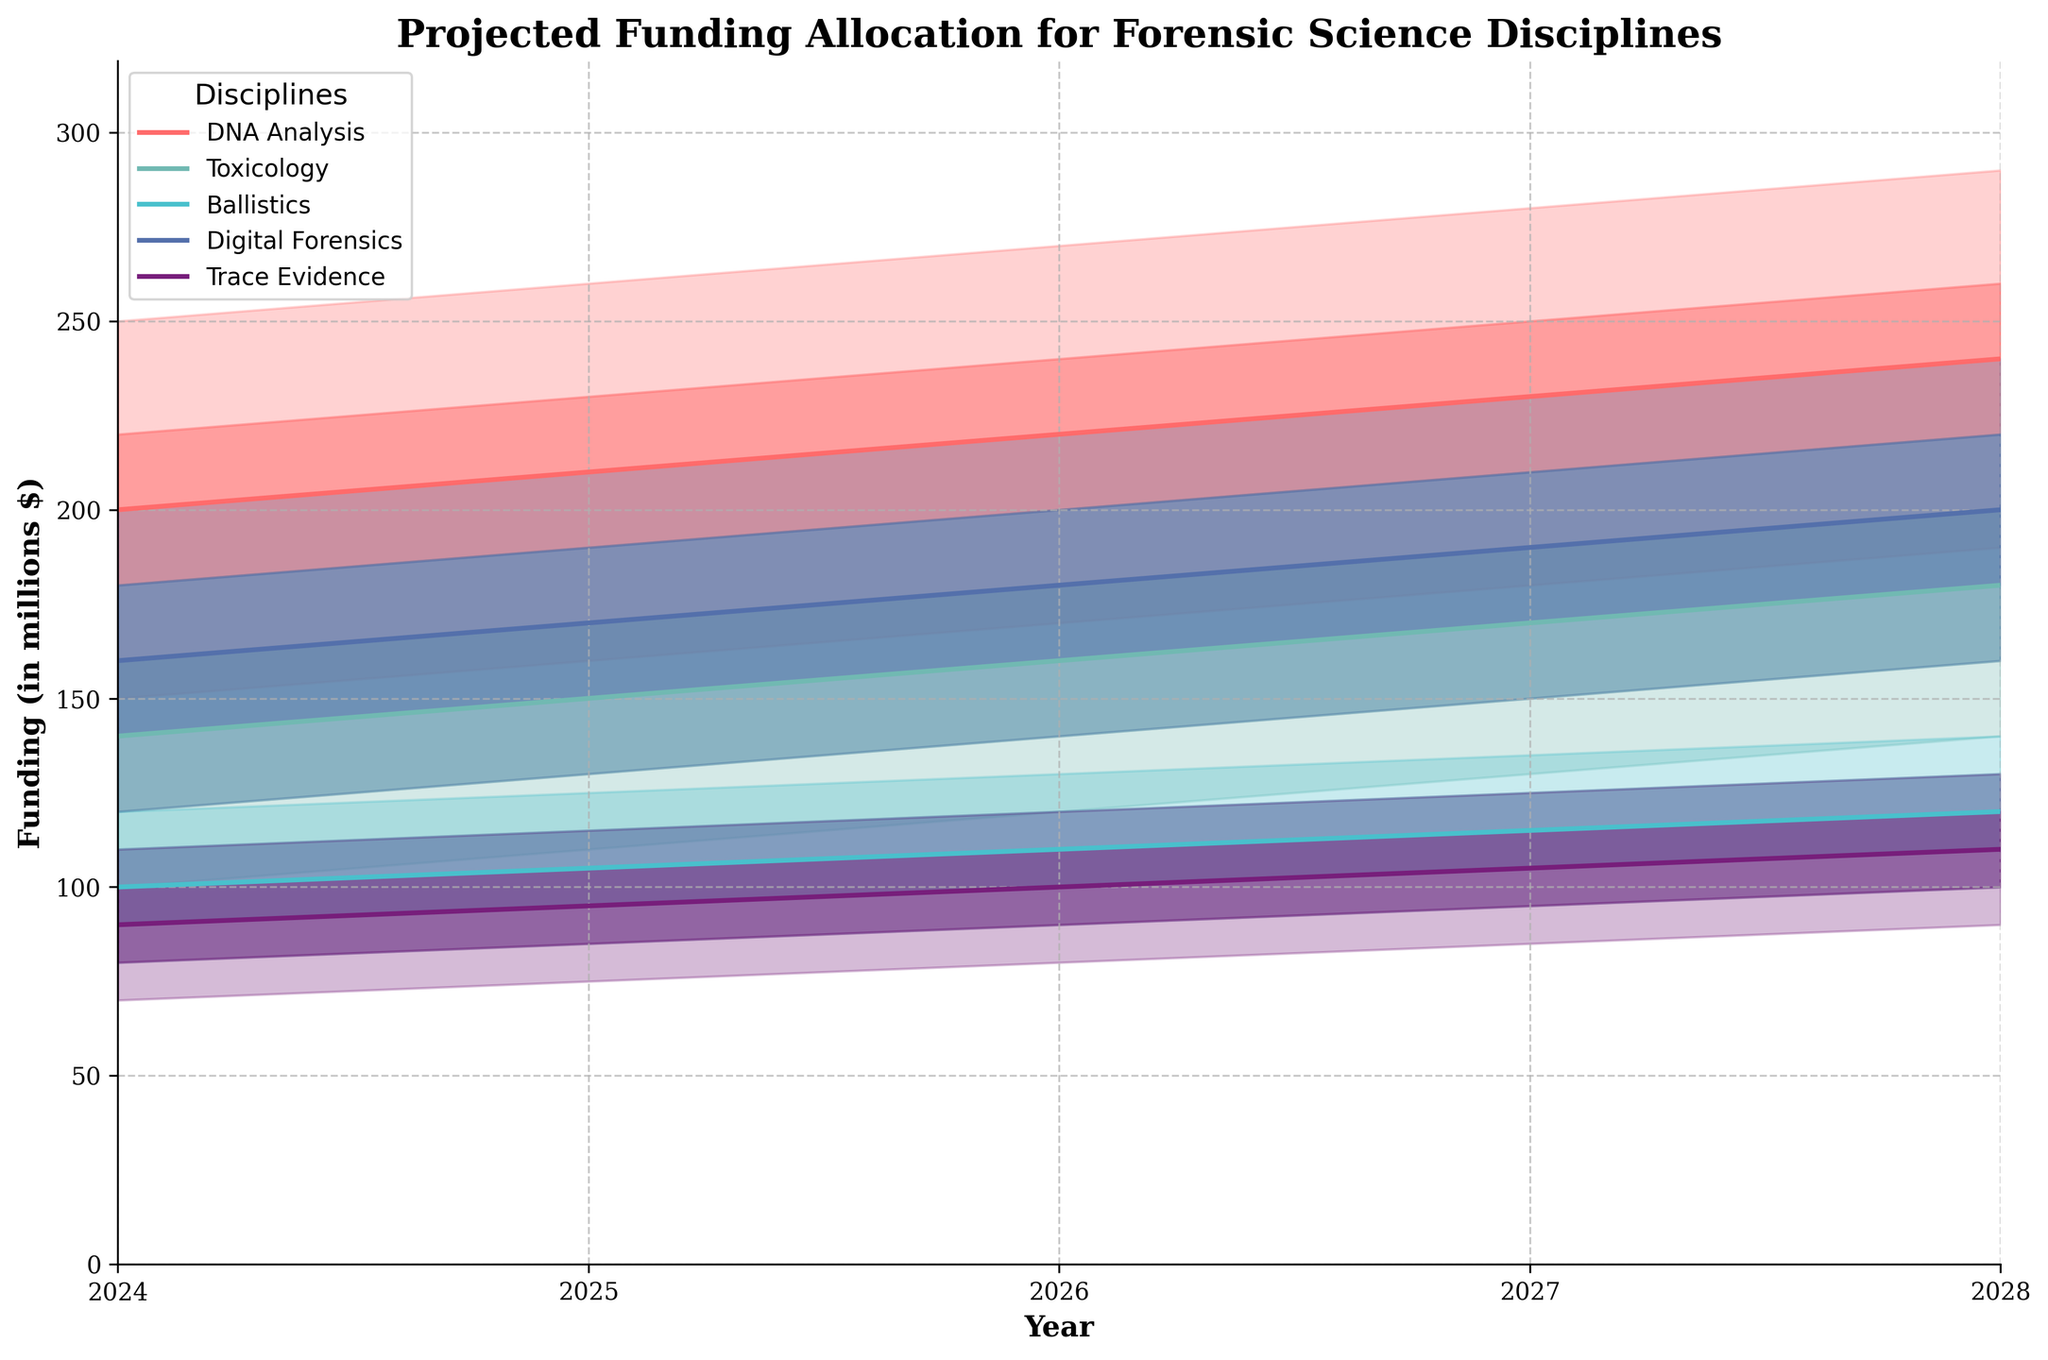what is the title of the figure? The title of the figure is written at the top and usually summarizes the main conclusion or focus of the visualization. In this case, the title is "Projected Funding Allocation for Forensic Science Disciplines".
Answer: Projected Funding Allocation for Forensic Science Disciplines how many years are projected in the figure? Look at the x-axis which shows the time span broken into yearly intervals. The data begins in 2024 and ends in 2028, inclusive of both years. Counting these years gives 5 years.
Answer: Five years Which forensic science discipline is projected to receive the highest funding in 2028 at the Mid value? Look at the plot lines for each discipline at the year 2028 on the x-axis, then compare the Mid (median) funding values. DNA Analysis has the highest Mid value of 240 million dollars.
Answer: DNA Analysis What is the overall trend in funding allocation for Digital Forensics from 2024 to 2028? Examine the plot line for Digital Forensics and observe how the Mid values change over the time period from 2024 to 2028. Funding steadily increases from 160 million dollars to 200 million dollars.
Answer: Increasing Which category shows the least growth in Low-Mid funding from 2024 to 2028? Identify the Low-Mid funding for each category in both 2024 and 2028. Calculate the difference for each category. Trace Evidence changes from 80 to 100 million dollars, showing the least growth of 20 million dollars.
Answer: Trace Evidence What is the difference in the highest projected funding between DNA Analysis and Digital Forensics in 2027 at the High value? Check the High values for DNA Analysis and Digital Forensics in the year 2027. For DNA Analysis it is 280 million dollars, and for Digital Forensics it is 230 million dollars. The difference is 280 - 230.
Answer: 50 million dollars Looking at the Mid-High projections, which discipline shows the highest level of funding uncertainty in 2026? Determine the level of funding uncertainty by subtracting the Low-Mid value from the Mid-High value for each category in 2026. Higher differences indicate higher uncertainty. DNA Analysis varies from 200 to 240 million dollars, showing highest uncertainty of 40 million dollars.
Answer: DNA Analysis In 2025, how does the Mid funding for Toxicology compare to Digital Forensics? Refer to the Mid values for Toxicology and Digital Forensics in 2025. Toxicology is projected at 150 million dollars, while Digital Forensics is projected at 170. Digital Forensics has a higher funding than Toxicology.
Answer: Digital Forensics is higher What is the average of the Low funding values across all disciplines in 2024? Add all Low values for 2024 across the disciplines (150 + 100 + 80 + 120 + 70). Then, divide by the number of values, which is 5. (150 + 100 + 80 + 120 + 70) / 5.
Answer: 104 million dollars Which discipline shows consistent growth in funding from year to year in the Mid values? Observe the Mid values for each discipline across the years and check if they increase steadily. DNA Analysis shows consistent growth from 200 million dollars in 2024 to 240 million dollars in 2028.
Answer: DNA Analysis 